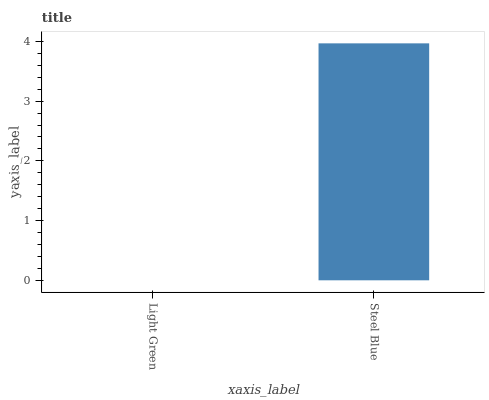Is Light Green the minimum?
Answer yes or no. Yes. Is Steel Blue the maximum?
Answer yes or no. Yes. Is Steel Blue the minimum?
Answer yes or no. No. Is Steel Blue greater than Light Green?
Answer yes or no. Yes. Is Light Green less than Steel Blue?
Answer yes or no. Yes. Is Light Green greater than Steel Blue?
Answer yes or no. No. Is Steel Blue less than Light Green?
Answer yes or no. No. Is Steel Blue the high median?
Answer yes or no. Yes. Is Light Green the low median?
Answer yes or no. Yes. Is Light Green the high median?
Answer yes or no. No. Is Steel Blue the low median?
Answer yes or no. No. 